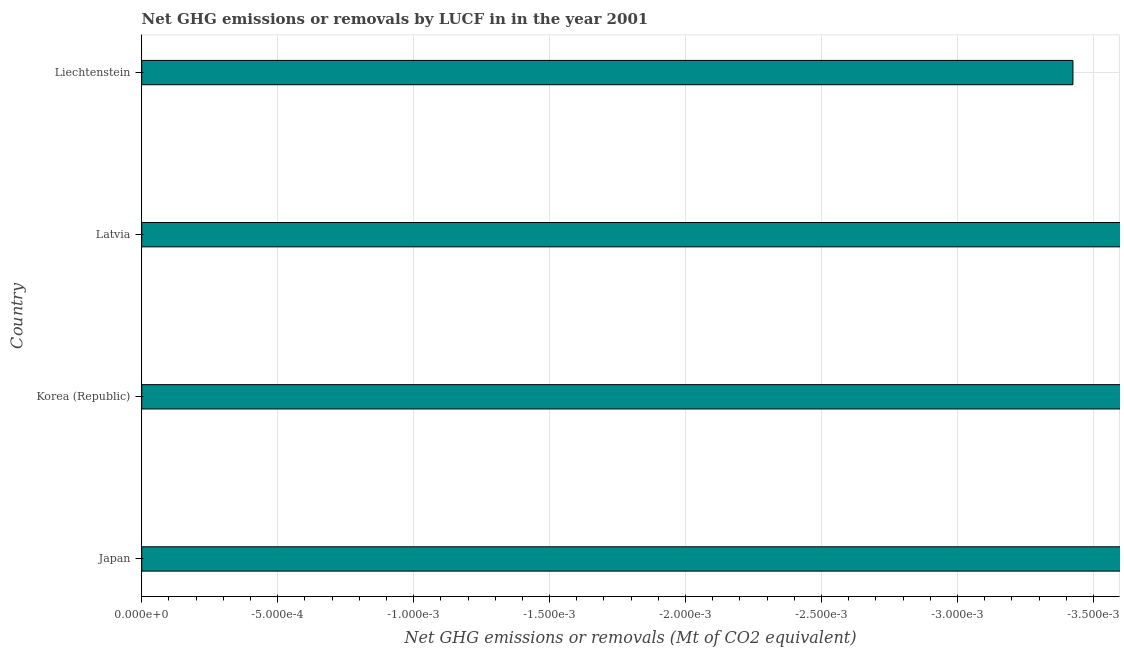What is the title of the graph?
Keep it short and to the point. Net GHG emissions or removals by LUCF in in the year 2001. What is the label or title of the X-axis?
Provide a succinct answer. Net GHG emissions or removals (Mt of CO2 equivalent). What is the label or title of the Y-axis?
Provide a succinct answer. Country. What is the ghg net emissions or removals in Japan?
Your answer should be compact. 0. Across all countries, what is the minimum ghg net emissions or removals?
Your response must be concise. 0. What is the average ghg net emissions or removals per country?
Your answer should be compact. 0. Are all the bars in the graph horizontal?
Keep it short and to the point. Yes. How many countries are there in the graph?
Give a very brief answer. 4. What is the difference between two consecutive major ticks on the X-axis?
Ensure brevity in your answer.  0. Are the values on the major ticks of X-axis written in scientific E-notation?
Give a very brief answer. Yes. What is the Net GHG emissions or removals (Mt of CO2 equivalent) of Japan?
Offer a terse response. 0. What is the Net GHG emissions or removals (Mt of CO2 equivalent) of Korea (Republic)?
Your answer should be very brief. 0. What is the Net GHG emissions or removals (Mt of CO2 equivalent) of Latvia?
Provide a short and direct response. 0. 